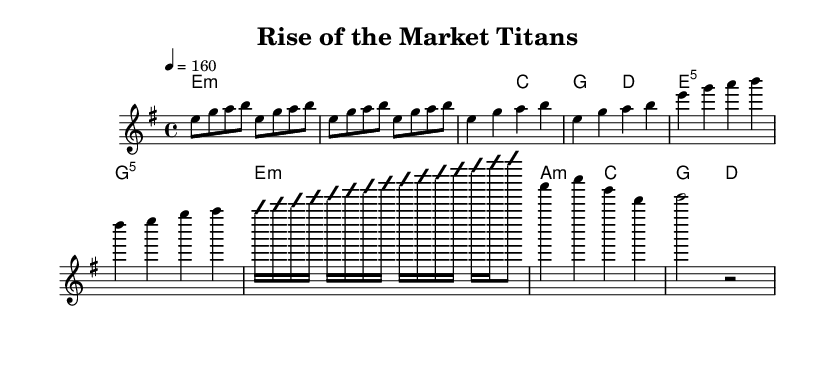What is the key signature of this music? The key signature is E minor, which has one sharp (F#) and is indicated by the presence of the ‘e’ on the staff.
Answer: E minor What is the time signature of this music? The time signature is 4/4, as shown at the beginning of the piece which denotes four beats per measure with each quarter note receiving one beat.
Answer: 4/4 What is the tempo marking for this piece? The tempo marking is 160 beats per minute, indicated by the number in the tempo text at the beginning of the music.
Answer: 160 How many measures are in the chorus section? The chorus section consists of two measures, as counted from the score where the chorus begins until it ends.
Answer: 2 measures What is the first note of the melody? The first note of the melody is E, as indicated by the first note in the melody line.
Answer: E Which section includes a guitar solo? The guitar solo is included as a separate section labeled "Guitar Solo," situated after the verse and before the bridge in the music.
Answer: Guitar Solo How many chords are played during the bridge section? The bridge section contains two chords, which are indicated clearly in the harmonies part during the bridge.
Answer: 2 chords 